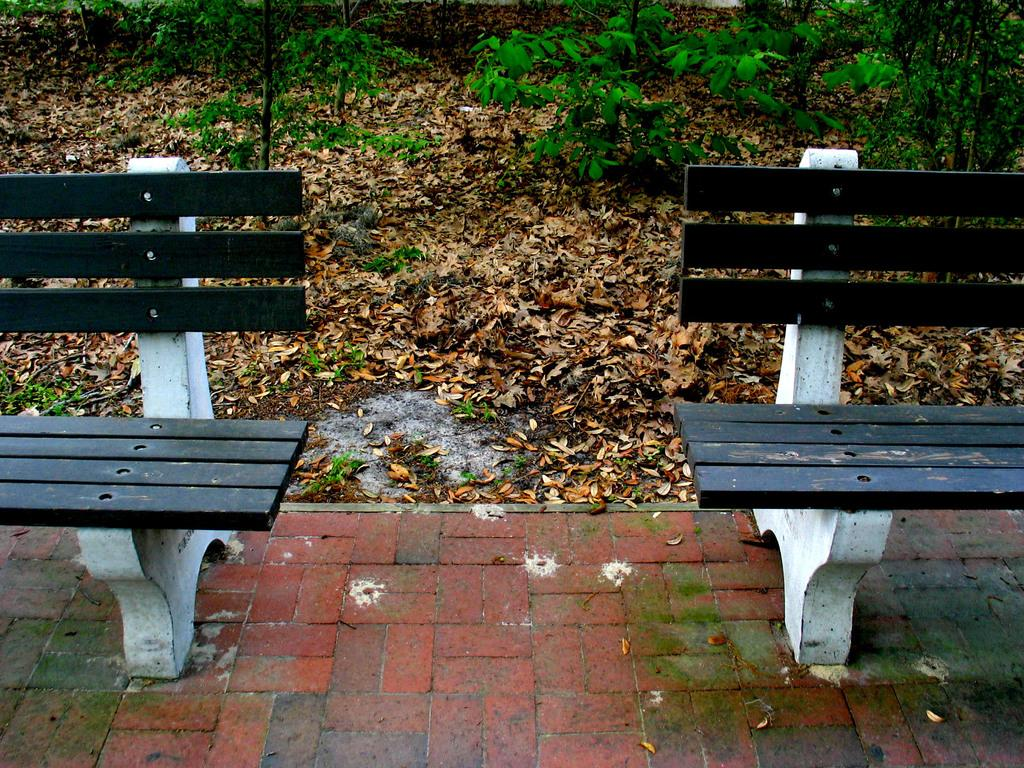What type of seating is present in the image? There are benches in the image. What other objects or features can be seen in the image? There are plants and leaves visible in the image. How many girls are sitting on the benches in the image? There is no mention of girls in the image, so we cannot determine the number of girls present. 